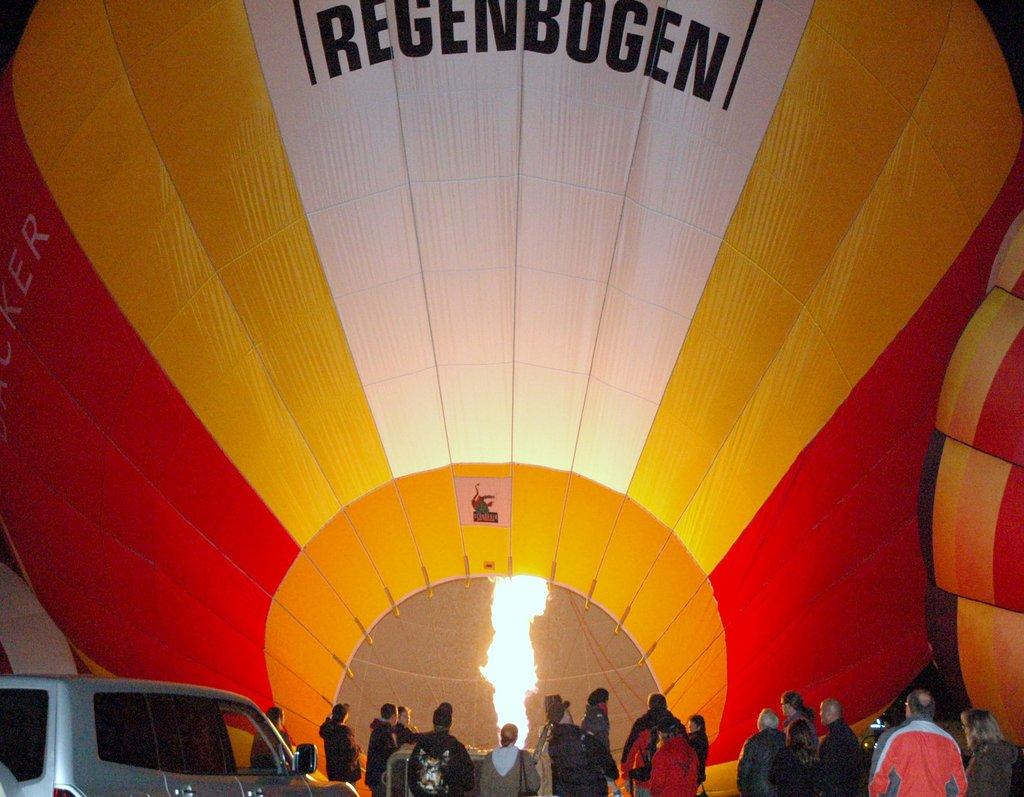What type of transportation is featured in the image? There is a vehicle in the image. What are the hot air balloons doing in the image? The hot air balloons are present in the image. Can you describe the group of people in the image? There is a group of people standing in the image. What type of lock is being used to secure the hot air balloons in the image? There is no lock present in the image; the hot air balloons are not secured. 